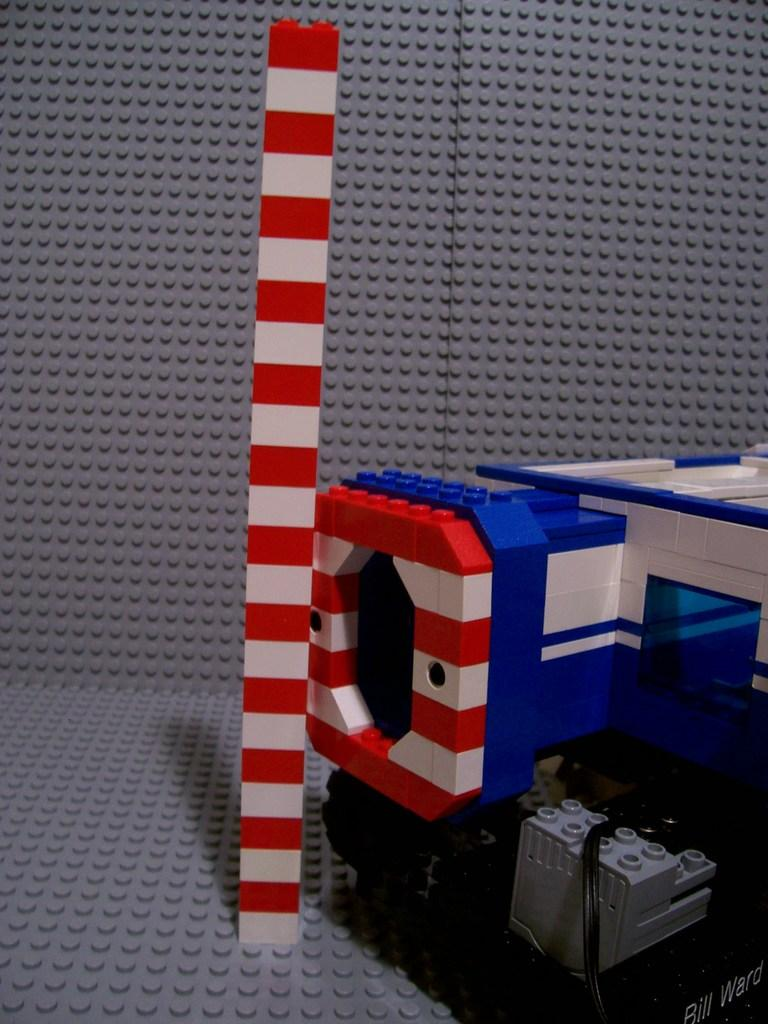What is the main structure visible in the image? There is a pole in the image. What type of objects are made of Lego in the image? The objects made of Lego in the image are not specified, but they are present. What type of mask is the writer wearing in the image? There is no writer or mask present in the image; it only features a pole and objects made of Lego. 